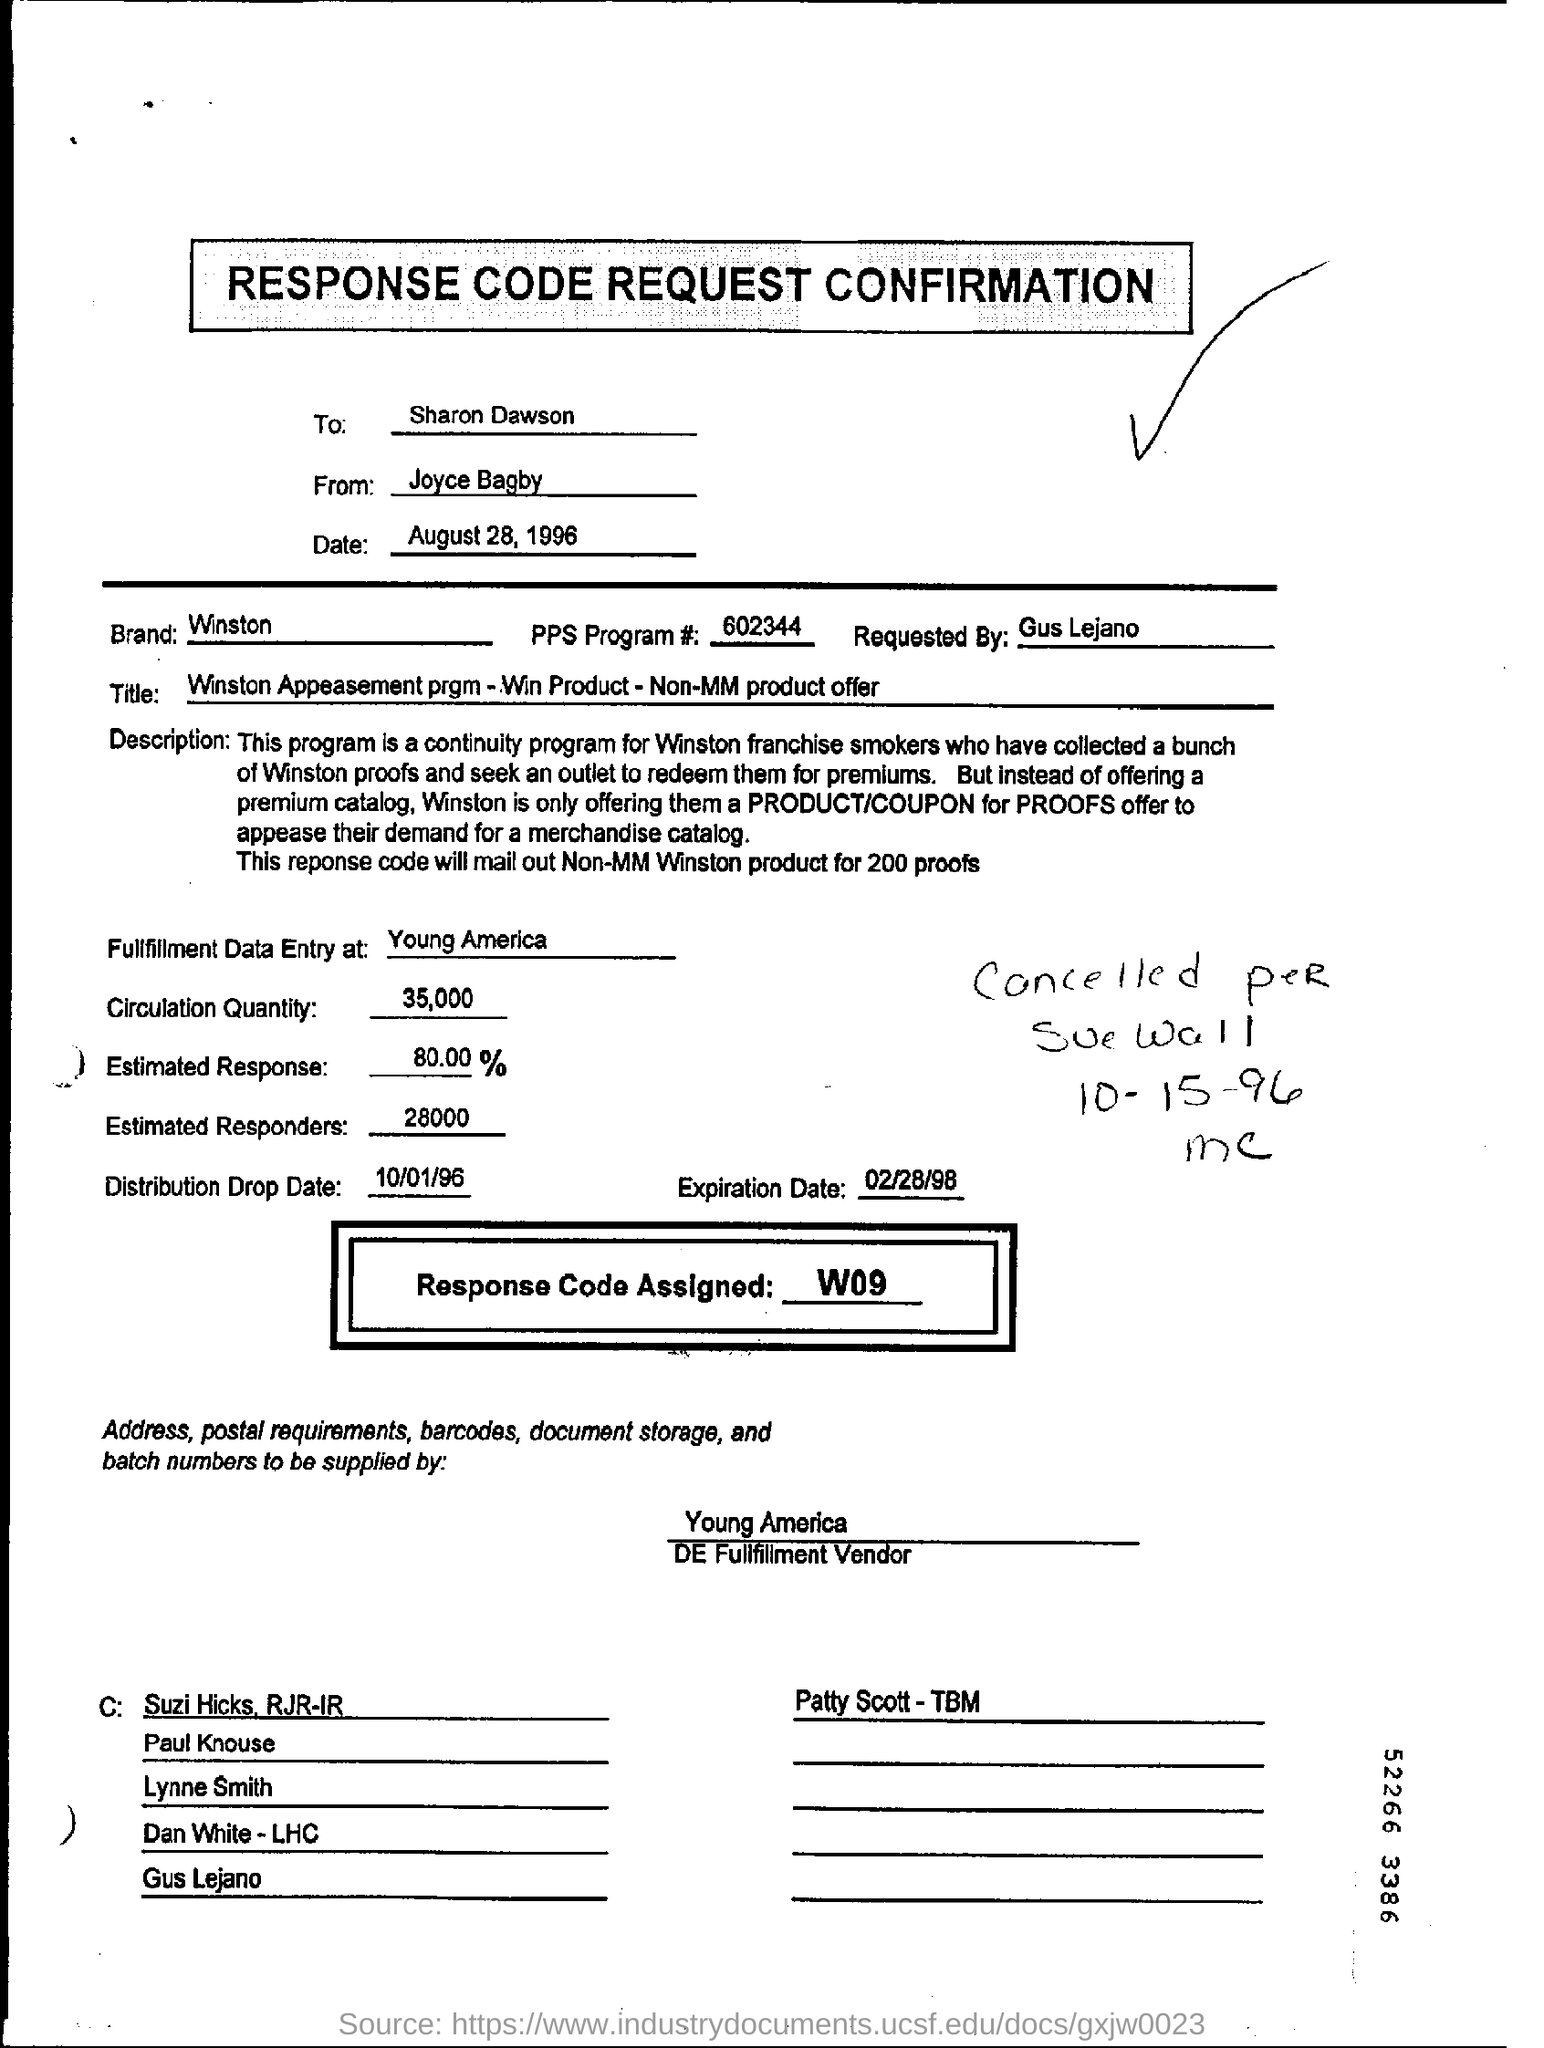Draw attention to some important aspects in this diagram. Please mention to whom the response code request confirmation is to be sent. The response code request confirmation is being sent to Sharon Dawson. The title that is entered in the form is "Winston Appeasement prgm - Win Product - Non-MM product offer. The response code request confirmation was sent to Sharon Dawson by Joyce Bagby. The estimated response is 80%. The response code assigned for this confirmation request is W09.. 